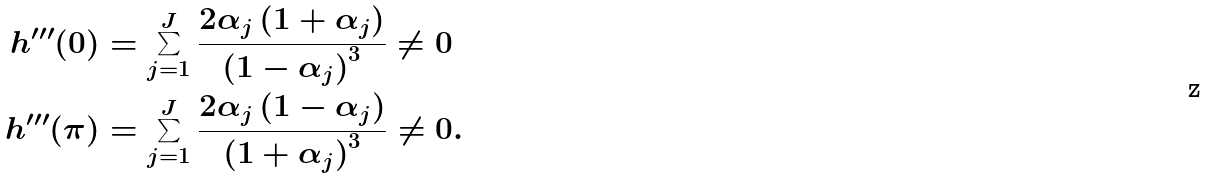<formula> <loc_0><loc_0><loc_500><loc_500>h ^ { \prime \prime \prime } ( 0 ) & = \sum _ { j = 1 } ^ { J } \frac { 2 \alpha _ { j } \left ( 1 + \alpha _ { j } \right ) } { \left ( 1 - \alpha _ { j } \right ) ^ { 3 } } \neq 0 \\ h ^ { \prime \prime \prime } ( \pi ) & = \sum _ { j = 1 } ^ { J } \frac { 2 \alpha _ { j } \left ( 1 - \alpha _ { j } \right ) } { \left ( 1 + \alpha _ { j } \right ) ^ { 3 } } \neq 0 .</formula> 